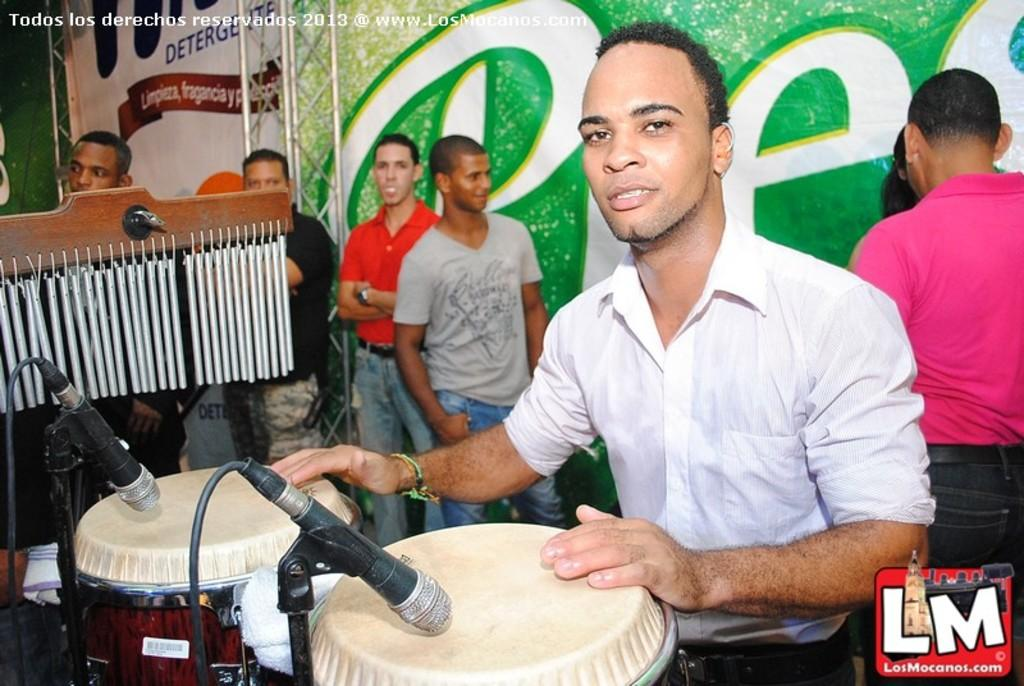What is the man in the image doing? The man is playing the drums. What equipment is in front of the man? There are two microphones in front of the man. Can you describe the background of the image? There are people standing in the background of the image, and there is a poster visible. What type of window is visible in the image? There is no window present in the image. 